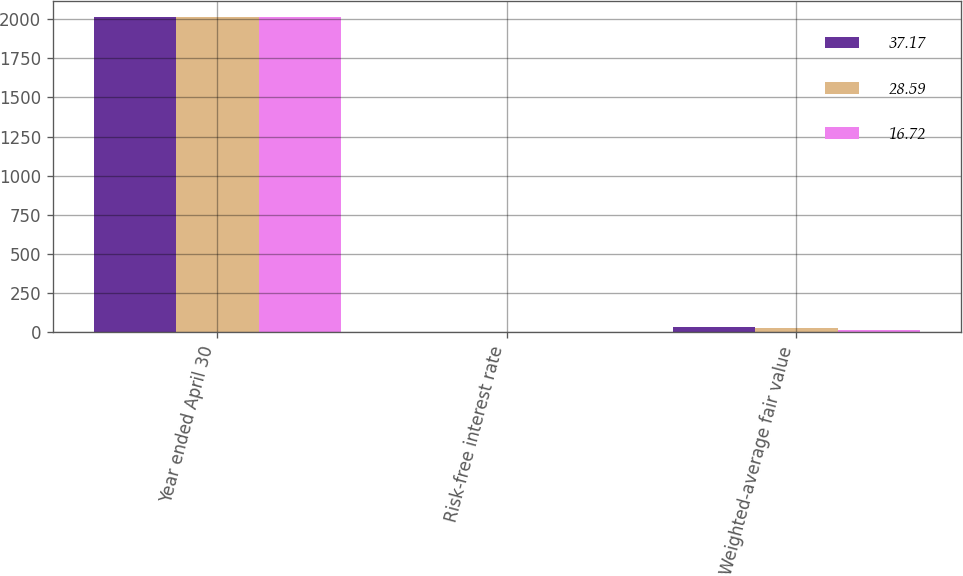Convert chart to OTSL. <chart><loc_0><loc_0><loc_500><loc_500><stacked_bar_chart><ecel><fcel>Year ended April 30<fcel>Risk-free interest rate<fcel>Weighted-average fair value<nl><fcel>37.17<fcel>2015<fcel>0.81<fcel>37.17<nl><fcel>28.59<fcel>2014<fcel>0.61<fcel>28.59<nl><fcel>16.72<fcel>2013<fcel>0.4<fcel>16.72<nl></chart> 